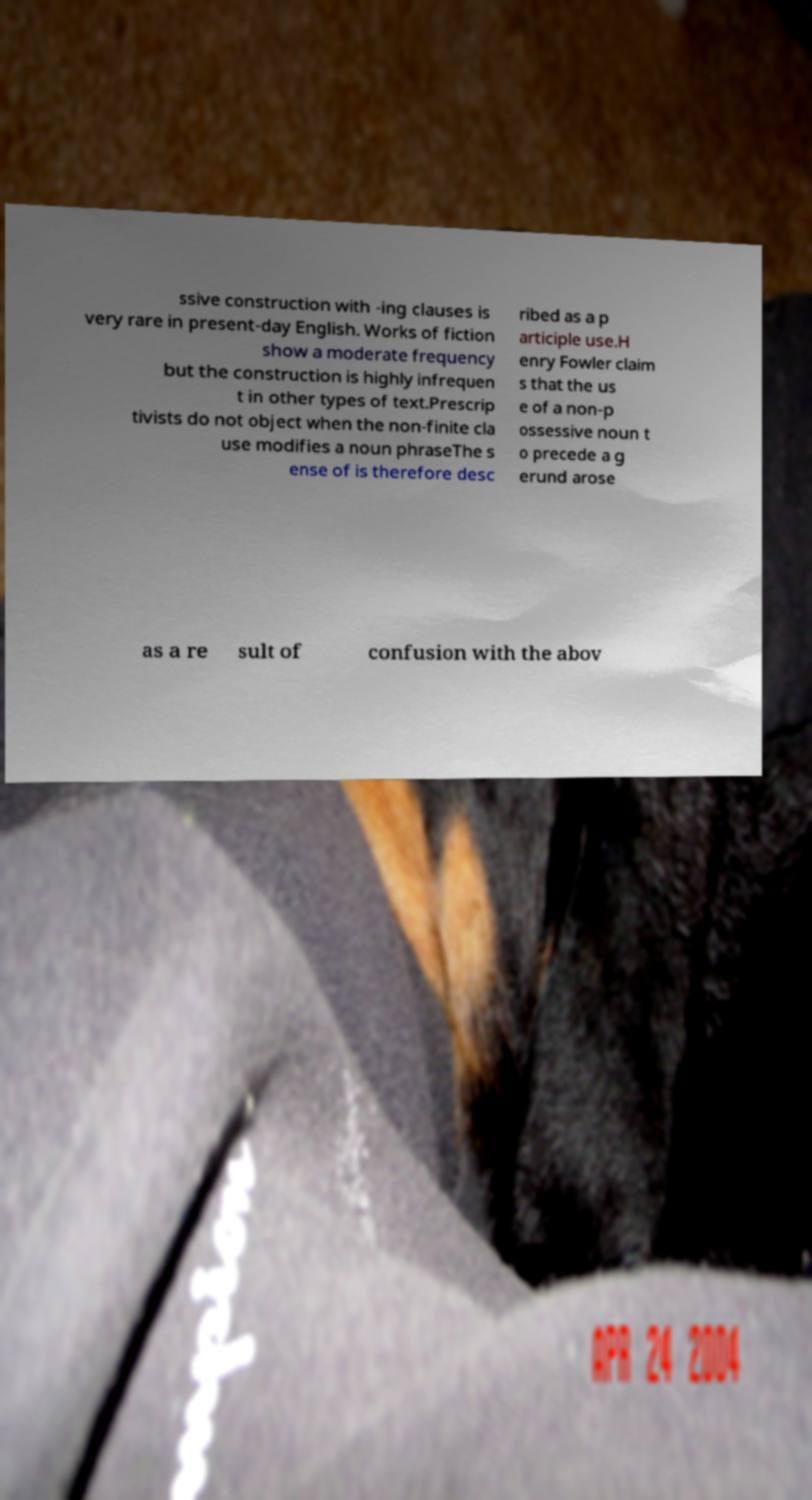Can you accurately transcribe the text from the provided image for me? ssive construction with -ing clauses is very rare in present-day English. Works of fiction show a moderate frequency but the construction is highly infrequen t in other types of text.Prescrip tivists do not object when the non-finite cla use modifies a noun phraseThe s ense of is therefore desc ribed as a p articiple use.H enry Fowler claim s that the us e of a non-p ossessive noun t o precede a g erund arose as a re sult of confusion with the abov 